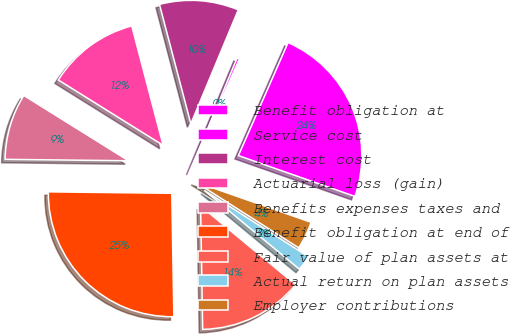Convert chart. <chart><loc_0><loc_0><loc_500><loc_500><pie_chart><fcel>Benefit obligation at<fcel>Service cost<fcel>Interest cost<fcel>Actuarial loss (gain)<fcel>Benefits expenses taxes and<fcel>Benefit obligation at end of<fcel>Fair value of plan assets at<fcel>Actual return on plan assets<fcel>Employer contributions<nl><fcel>23.77%<fcel>0.31%<fcel>10.37%<fcel>12.04%<fcel>8.69%<fcel>25.45%<fcel>13.72%<fcel>1.99%<fcel>3.66%<nl></chart> 